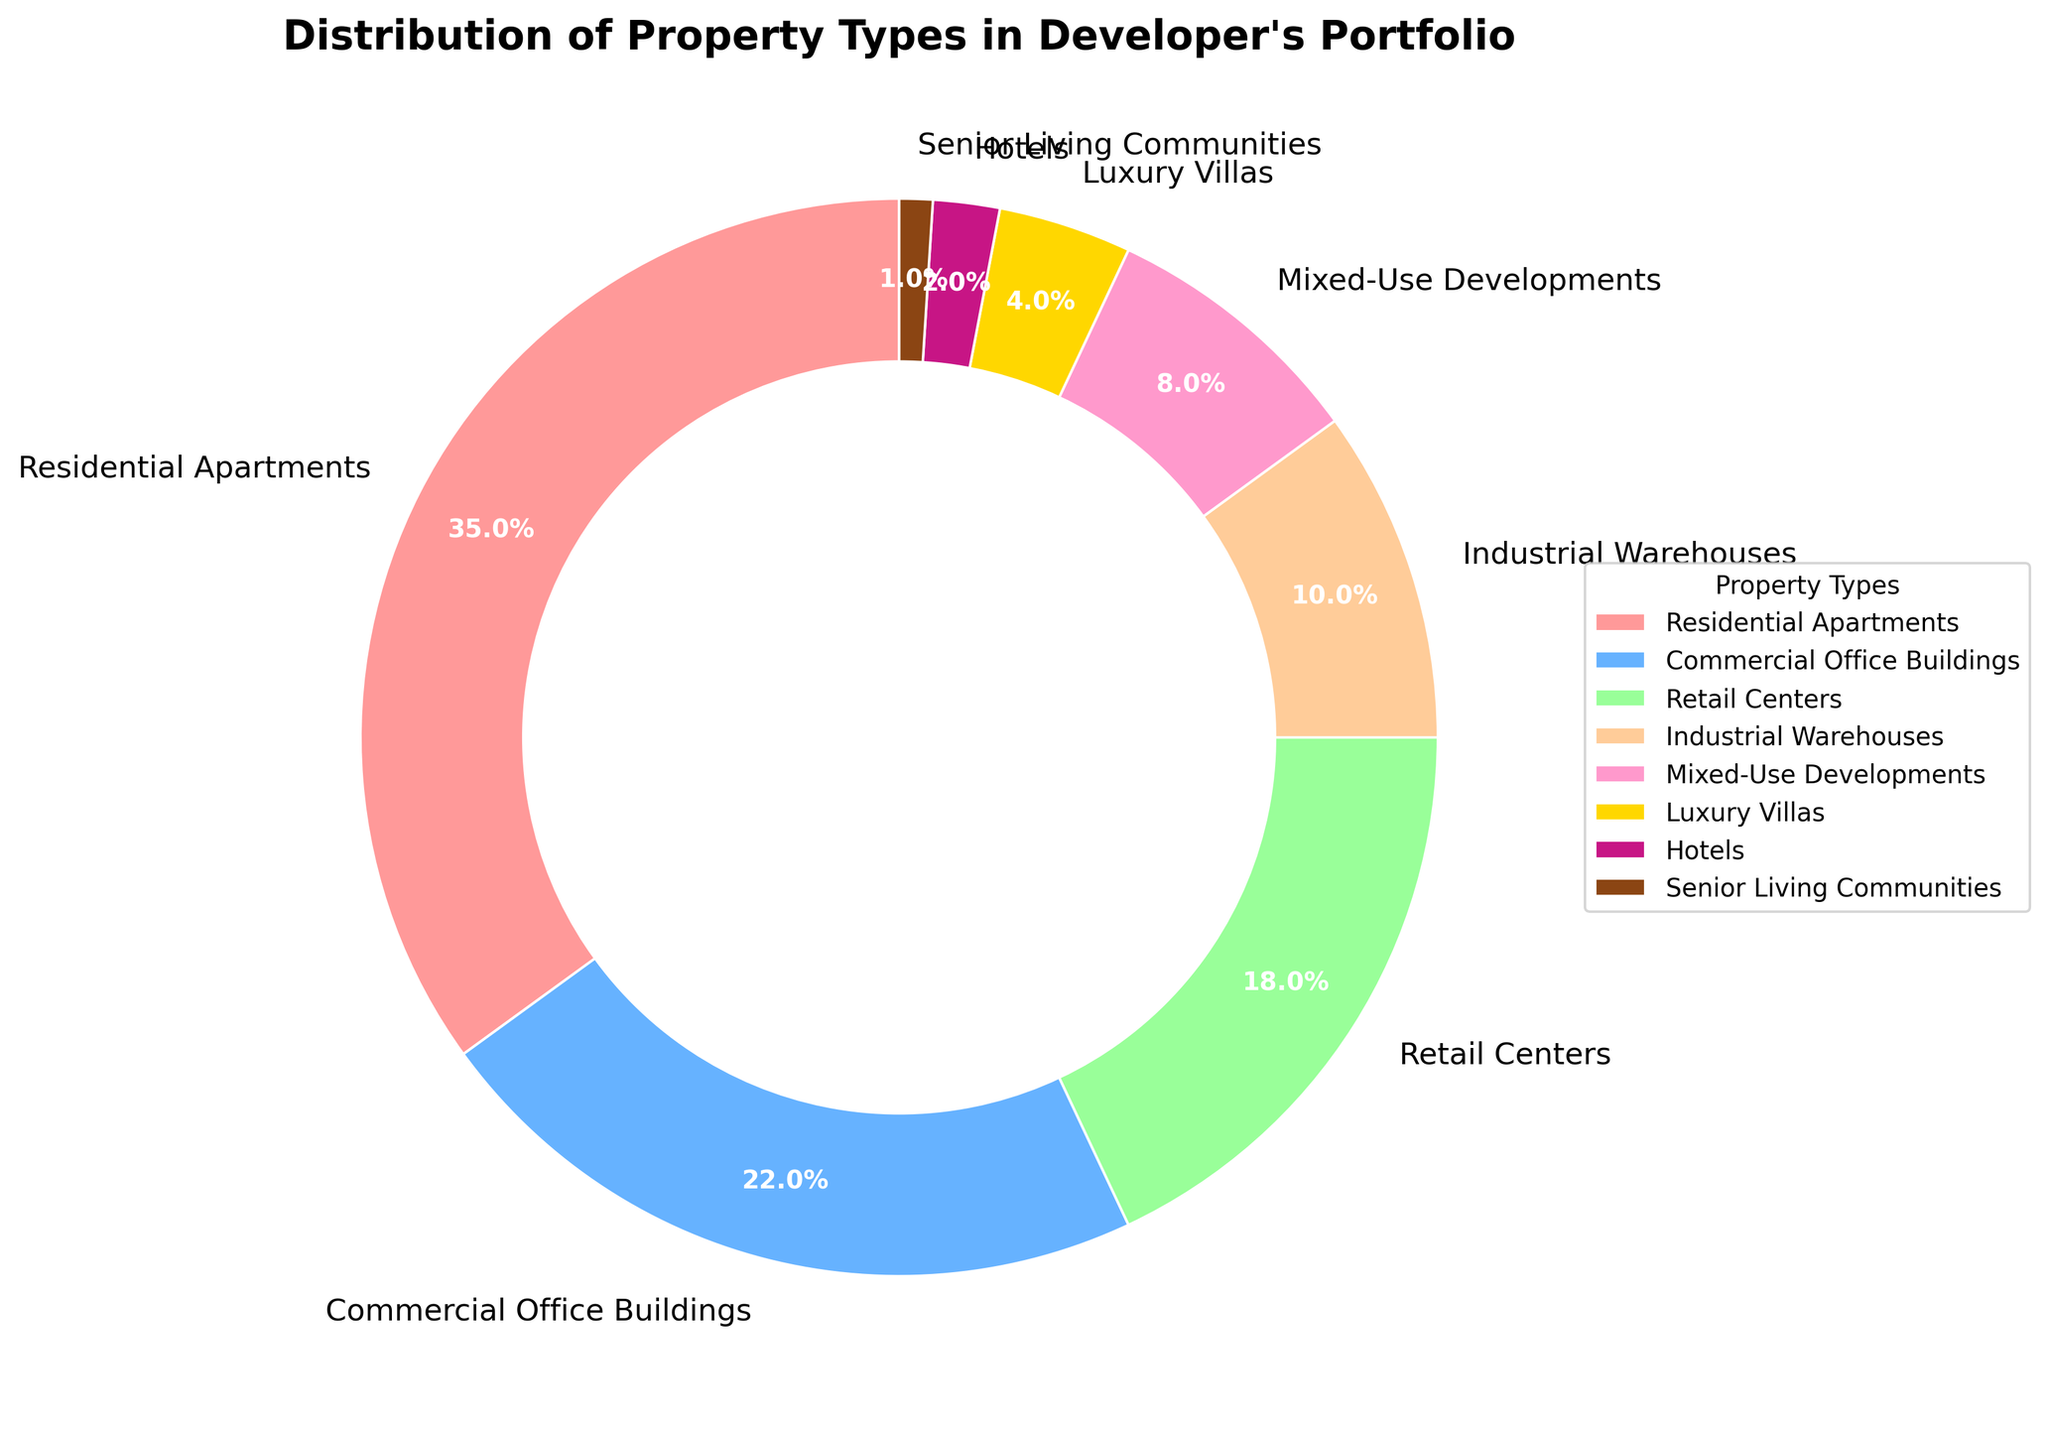Which property type has the highest percentage in the portfolio? Look for the property type with the largest segment in the pie chart. The "Residential Apartments" segment is the largest at 35%.
Answer: Residential Apartments How does the percentage of Mixed-Use Developments compare to Hotels? Identify the percentages for both property types: Mixed-Use Developments (8%) and Hotels (2%). Mixed-Use Developments have a higher percentage.
Answer: Mixed-Use Developments have a higher percentage What is the combined percentage of Commercial Office Buildings and Industrial Warehouses? Sum the percentages of Commercial Office Buildings (22%) and Industrial Warehouses (10%): 22% + 10% = 32%.
Answer: 32% Which two property types make up less than 5% each of the portfolio? Identify the property types with percentages less than 5%. These are Luxury Villas (4%) and Hotels (2%).
Answer: Luxury Villas and Hotels What is the total percentage of all property types categorized as residential (Residential Apartments, Luxury Villas, Senior Living Communities)? Sum the percentages of Residential Apartments (35%), Luxury Villas (4%), and Senior Living Communities (1%): 35% + 4% + 1% = 40%.
Answer: 40% Is the percentage of Retail Centers greater than or less than that of Mixed-Use Developments? Compare the percentages of Retail Centers (18%) and Mixed-Use Developments (8%). Retail Centers have a higher percentage.
Answer: Retail Centers have a greater percentage What is the difference in percentage between Commercial Office Buildings and Residential Apartments? Subtract the percentage of Commercial Office Buildings (22%) from that of Residential Apartments (35%): 35% - 22% = 13%.
Answer: 13% How many property types have a percentage greater than 10%? Count the property types with percentages greater than 10%: Residential Apartments (35%), Commercial Office Buildings (22%), and Retail Centers (18%). There are three property types.
Answer: 3 What's the total percentage represented by properties with less than 10% each, and which property types are these? Sum the percentages of property types with less than 10%: Industrial Warehouses (10%), Mixed-Use Developments (8%), Luxury Villas (4%), Hotels (2%), and Senior Living Communities (1%): 10% + 8% + 4% + 2% + 1% = 25%. The property types are Industrial Warehouses, Mixed-Use Developments, Luxury Villas, Hotels, and Senior Living Communities.
Answer: 25% and the property types are Industrial Warehouses, Mixed-Use Developments, Luxury Villas, Hotels, and Senior Living Communities What color is used to represent Retail Centers in the chart? Identify the segment labeled as Retail Centers and note its color. Retail Centers are represented by the color green.
Answer: Green 